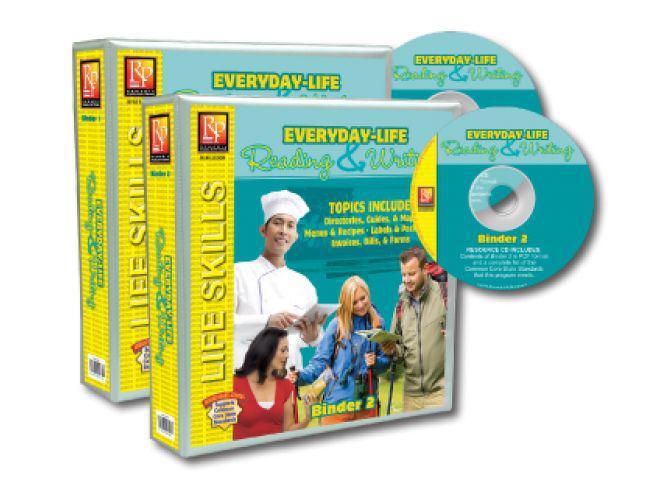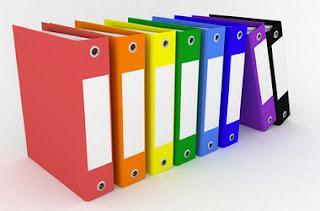The first image is the image on the left, the second image is the image on the right. Evaluate the accuracy of this statement regarding the images: "In one image, bright colored binders have large white labels on the narrow closed end.". Is it true? Answer yes or no. Yes. The first image is the image on the left, the second image is the image on the right. For the images displayed, is the sentence "Right image shows multiple different solid colored binders of the same size." factually correct? Answer yes or no. Yes. 